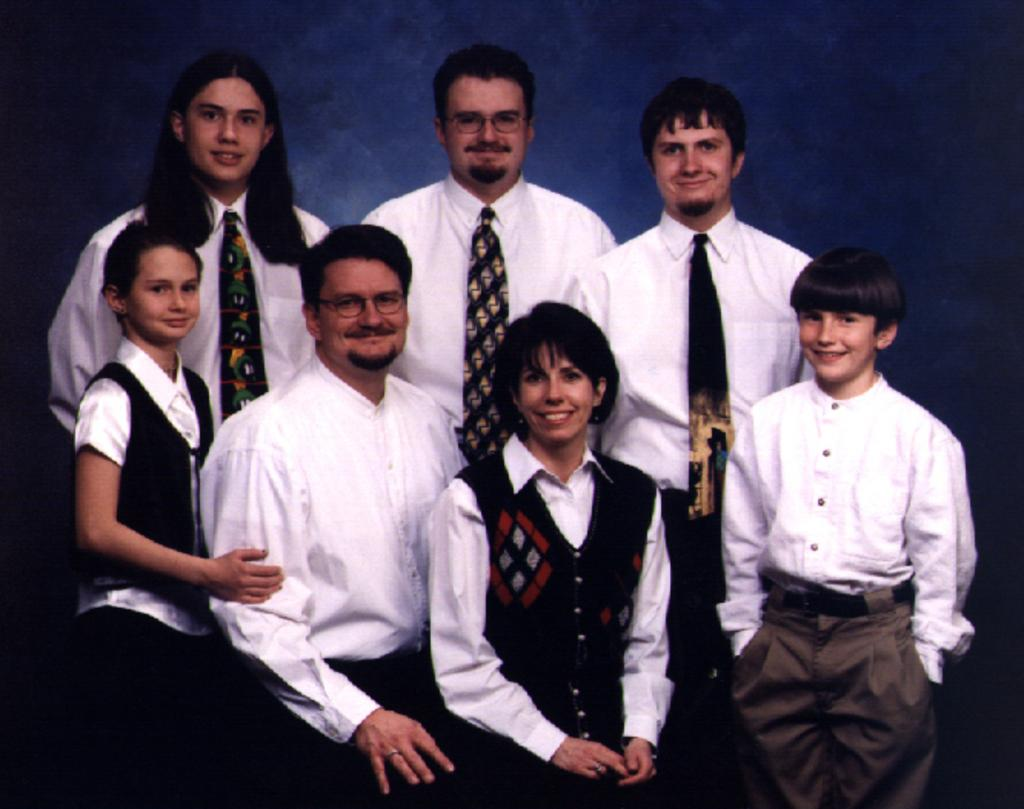How many people are present in the image? There are five persons standing and two persons sitting in the image, making a total of seven people. What are the people in the image doing? The people are either standing or sitting in the image. What is the color of the background in the image? The background color is blue. What type of plastic is used to create the carriage in the image? There is no carriage present in the image, so it is not possible to determine what type of plastic might be used. 